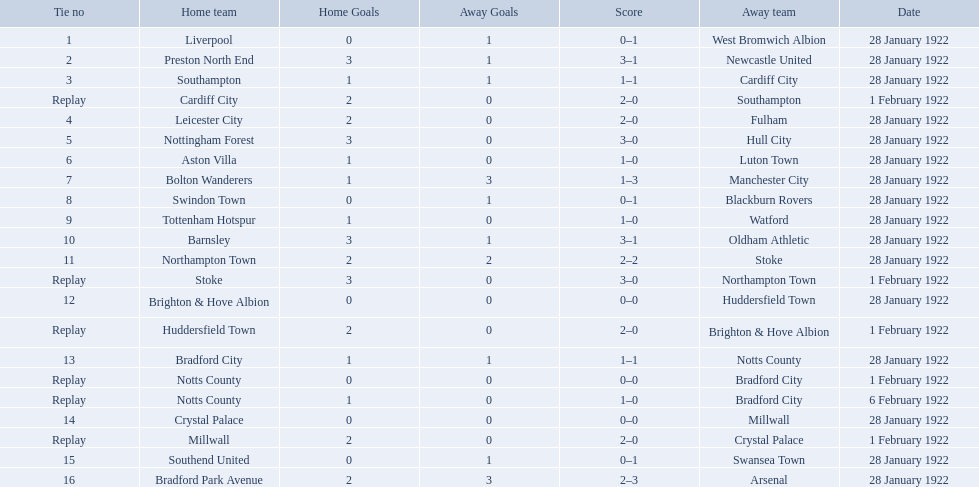Which team had a score of 0-1? Liverpool. Which team had a replay? Cardiff City. Which team had the same score as aston villa? Tottenham Hotspur. What was the score in the aston villa game? 1–0. Which other team had an identical score? Tottenham Hotspur. Help me parse the entirety of this table. {'header': ['Tie no', 'Home team', 'Home Goals', 'Away Goals', 'Score', 'Away team', 'Date'], 'rows': [['1', 'Liverpool', '0', '1', '0–1', 'West Bromwich Albion', '28 January 1922'], ['2', 'Preston North End', '3', '1', '3–1', 'Newcastle United', '28 January 1922'], ['3', 'Southampton', '1', '1', '1–1', 'Cardiff City', '28 January 1922'], ['Replay', 'Cardiff City', '2', '0', '2–0', 'Southampton', '1 February 1922'], ['4', 'Leicester City', '2', '0', '2–0', 'Fulham', '28 January 1922'], ['5', 'Nottingham Forest', '3', '0', '3–0', 'Hull City', '28 January 1922'], ['6', 'Aston Villa', '1', '0', '1–0', 'Luton Town', '28 January 1922'], ['7', 'Bolton Wanderers', '1', '3', '1–3', 'Manchester City', '28 January 1922'], ['8', 'Swindon Town', '0', '1', '0–1', 'Blackburn Rovers', '28 January 1922'], ['9', 'Tottenham Hotspur', '1', '0', '1–0', 'Watford', '28 January 1922'], ['10', 'Barnsley', '3', '1', '3–1', 'Oldham Athletic', '28 January 1922'], ['11', 'Northampton Town', '2', '2', '2–2', 'Stoke', '28 January 1922'], ['Replay', 'Stoke', '3', '0', '3–0', 'Northampton Town', '1 February 1922'], ['12', 'Brighton & Hove Albion', '0', '0', '0–0', 'Huddersfield Town', '28 January 1922'], ['Replay', 'Huddersfield Town', '2', '0', '2–0', 'Brighton & Hove Albion', '1 February 1922'], ['13', 'Bradford City', '1', '1', '1–1', 'Notts County', '28 January 1922'], ['Replay', 'Notts County', '0', '0', '0–0', 'Bradford City', '1 February 1922'], ['Replay', 'Notts County', '1', '0', '1–0', 'Bradford City', '6 February 1922'], ['14', 'Crystal Palace', '0', '0', '0–0', 'Millwall', '28 January 1922'], ['Replay', 'Millwall', '2', '0', '2–0', 'Crystal Palace', '1 February 1922'], ['15', 'Southend United', '0', '1', '0–1', 'Swansea Town', '28 January 1922'], ['16', 'Bradford Park Avenue', '2', '3', '2–3', 'Arsenal', '28 January 1922']]} 